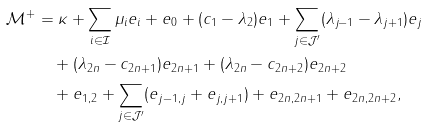<formula> <loc_0><loc_0><loc_500><loc_500>\mathcal { M } ^ { + } & = \kappa + \sum _ { i \in \mathcal { I } } \mu _ { i } e _ { i } + e _ { 0 } + ( c _ { 1 } - \lambda _ { 2 } ) e _ { 1 } + \sum _ { j \in \mathcal { J } ^ { \prime } } ( \lambda _ { j - 1 } - \lambda _ { j + 1 } ) e _ { j } \\ & \quad + ( \lambda _ { 2 n } - c _ { 2 n + 1 } ) e _ { 2 n + 1 } + ( \lambda _ { 2 n } - c _ { 2 n + 2 } ) e _ { 2 n + 2 } \\ & \quad + e _ { 1 , 2 } + \sum _ { j \in \mathcal { J } ^ { \prime } } ( e _ { j - 1 , j } + e _ { j , j + 1 } ) + e _ { 2 n , 2 n + 1 } + e _ { 2 n , 2 n + 2 } ,</formula> 